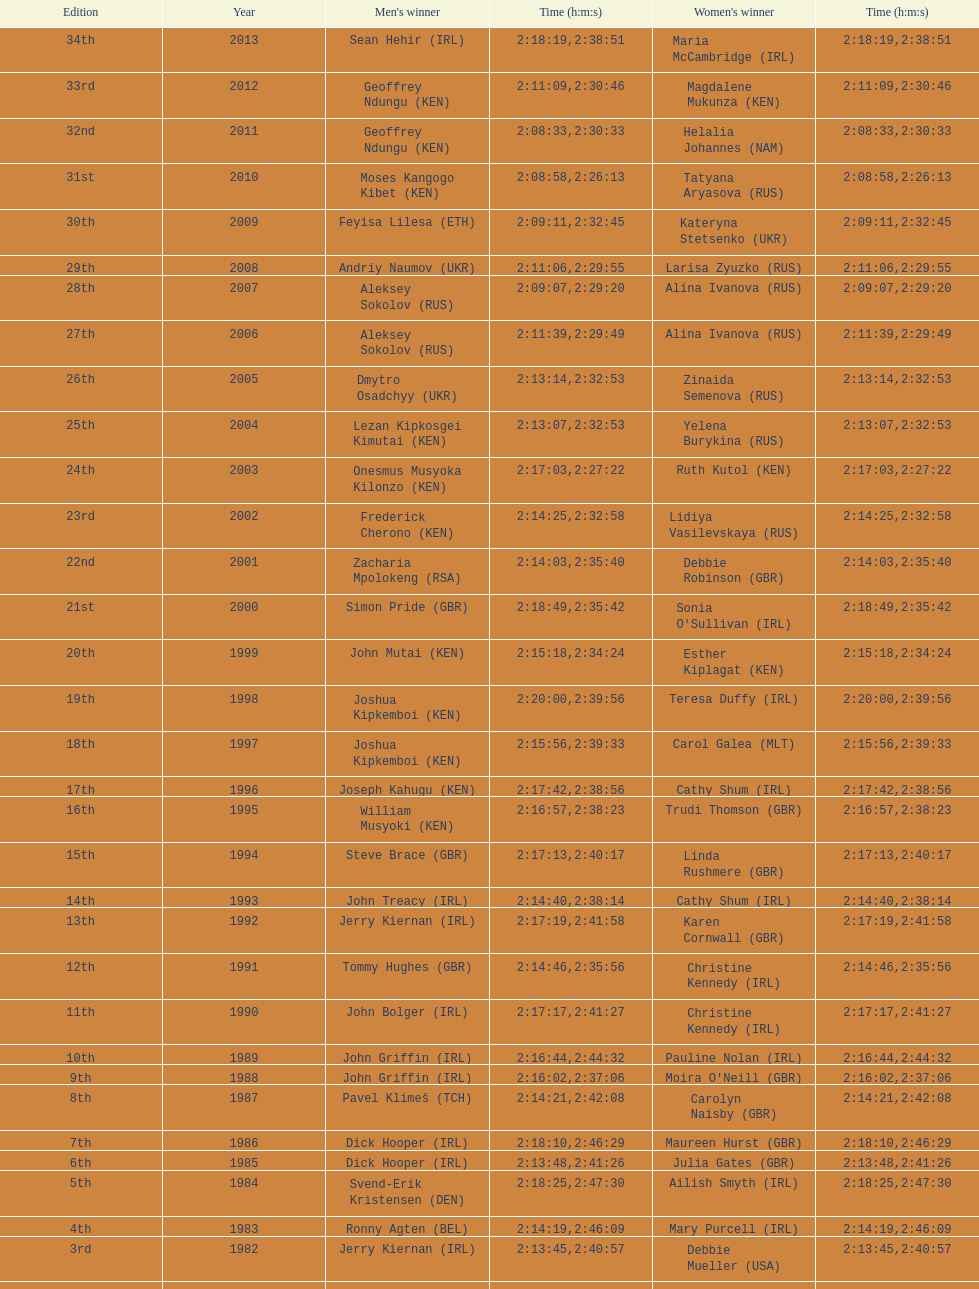Who had the maximum amount of time among all the runners? Maria McCambridge (IRL). 